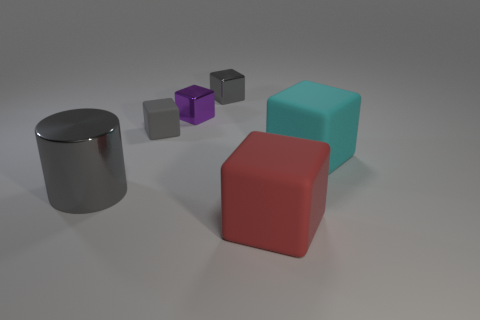There is a tiny purple thing that is the same material as the big gray cylinder; what is its shape? The tiny purple object shares the reflective material characteristics with the large gray cylinder, and it has the shape of a cube. 